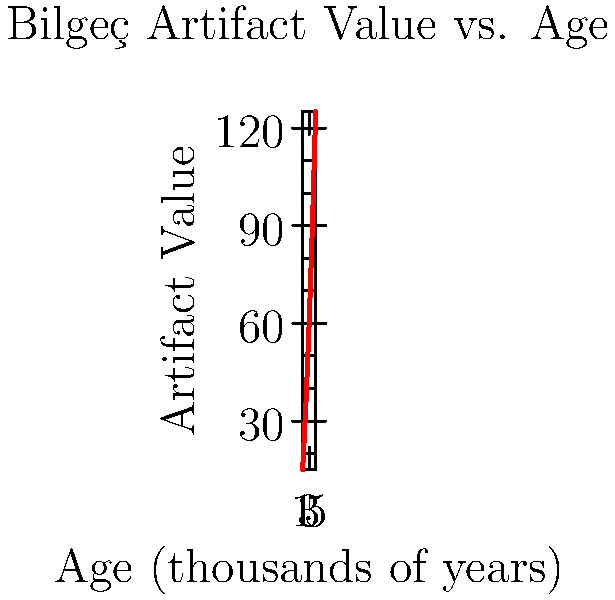Based on the graph showing the relationship between the age and value of Bilgeç's ancient artifacts, estimate the value of an artifact that is 3,500 years old. To estimate the value of a 3,500-year-old artifact, we need to follow these steps:

1. Observe that the graph shows a non-linear relationship between age and value.
2. Note that 3,500 years corresponds to 3.5 on the x-axis.
3. Locate the point on the x-axis at 3.5.
4. Draw an imaginary vertical line from this point until it intersects the curve.
5. From the intersection point, draw an imaginary horizontal line to the y-axis.
6. This line will intersect the y-axis between 70 and 80.

Using linear interpolation between the known points:
- At 3,000 years (x = 3), y ≈ 60
- At 4,000 years (x = 4), y ≈ 90

We can estimate that at 3,500 years:

$$ y ≈ 60 + \frac{3.5 - 3}{4 - 3} \cdot (90 - 60) = 60 + 0.5 \cdot 30 = 75 $$

Therefore, the estimated value for a 3,500-year-old artifact is approximately 75.
Answer: 75 